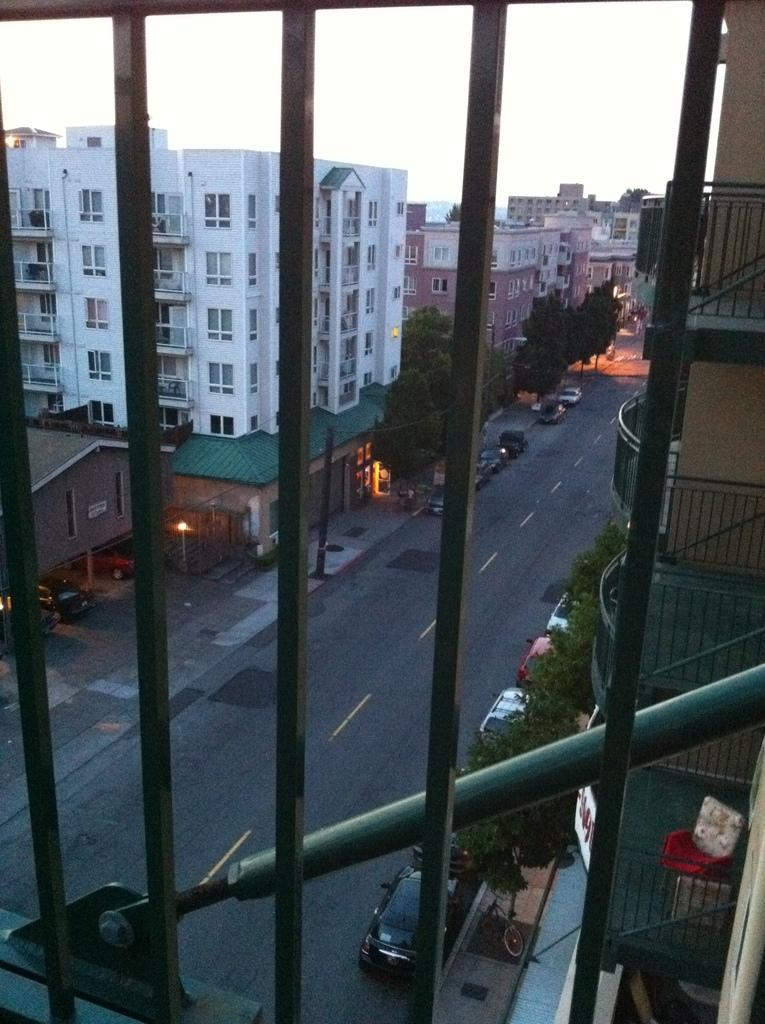What is the main object in the foreground of the image? There is a grille in the image. What can be seen behind the grille? There are buildings behind the grille. What type of vehicles are parked near the grille? Cars are parked at the corners of the road. What natural elements are visible in the image? There are plants and trees visible in the image. Can you see any boats in the image? No, there are no boats present in the image. What type of debt is being discussed in the image? There is no mention of debt in the image. 